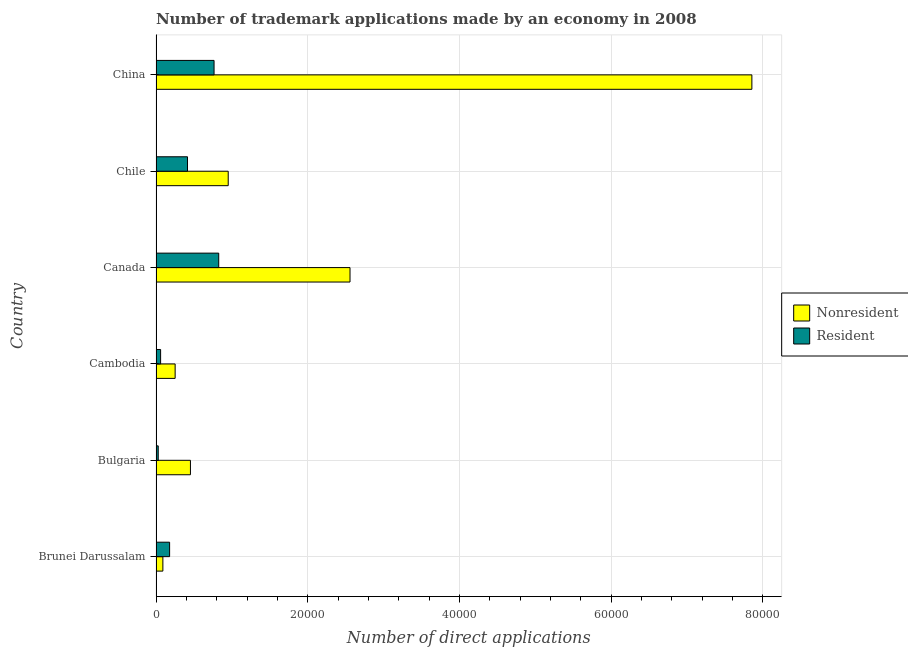Are the number of bars per tick equal to the number of legend labels?
Your response must be concise. Yes. How many bars are there on the 3rd tick from the top?
Make the answer very short. 2. What is the label of the 1st group of bars from the top?
Provide a short and direct response. China. In how many cases, is the number of bars for a given country not equal to the number of legend labels?
Your answer should be compact. 0. What is the number of trademark applications made by residents in Bulgaria?
Provide a short and direct response. 292. Across all countries, what is the maximum number of trademark applications made by non residents?
Ensure brevity in your answer.  7.86e+04. Across all countries, what is the minimum number of trademark applications made by non residents?
Keep it short and to the point. 904. In which country was the number of trademark applications made by residents maximum?
Offer a very short reply. Canada. In which country was the number of trademark applications made by residents minimum?
Make the answer very short. Bulgaria. What is the total number of trademark applications made by residents in the graph?
Give a very brief answer. 2.28e+04. What is the difference between the number of trademark applications made by non residents in Bulgaria and that in China?
Your answer should be compact. -7.40e+04. What is the difference between the number of trademark applications made by residents in Canada and the number of trademark applications made by non residents in Cambodia?
Your answer should be very brief. 5746. What is the average number of trademark applications made by residents per country?
Provide a succinct answer. 3793. What is the difference between the number of trademark applications made by residents and number of trademark applications made by non residents in China?
Your answer should be compact. -7.09e+04. What is the ratio of the number of trademark applications made by non residents in Canada to that in Chile?
Ensure brevity in your answer.  2.69. What is the difference between the highest and the second highest number of trademark applications made by residents?
Your response must be concise. 615. What is the difference between the highest and the lowest number of trademark applications made by non residents?
Give a very brief answer. 7.77e+04. In how many countries, is the number of trademark applications made by non residents greater than the average number of trademark applications made by non residents taken over all countries?
Keep it short and to the point. 2. What does the 2nd bar from the top in Cambodia represents?
Offer a terse response. Nonresident. What does the 1st bar from the bottom in Chile represents?
Make the answer very short. Nonresident. How many bars are there?
Your answer should be compact. 12. How many countries are there in the graph?
Your answer should be compact. 6. What is the difference between two consecutive major ticks on the X-axis?
Provide a short and direct response. 2.00e+04. Are the values on the major ticks of X-axis written in scientific E-notation?
Provide a short and direct response. No. Where does the legend appear in the graph?
Keep it short and to the point. Center right. How many legend labels are there?
Offer a very short reply. 2. How are the legend labels stacked?
Provide a succinct answer. Vertical. What is the title of the graph?
Ensure brevity in your answer.  Number of trademark applications made by an economy in 2008. What is the label or title of the X-axis?
Your response must be concise. Number of direct applications. What is the label or title of the Y-axis?
Offer a very short reply. Country. What is the Number of direct applications in Nonresident in Brunei Darussalam?
Keep it short and to the point. 904. What is the Number of direct applications of Resident in Brunei Darussalam?
Your answer should be compact. 1792. What is the Number of direct applications in Nonresident in Bulgaria?
Ensure brevity in your answer.  4538. What is the Number of direct applications in Resident in Bulgaria?
Keep it short and to the point. 292. What is the Number of direct applications of Nonresident in Cambodia?
Offer a terse response. 2521. What is the Number of direct applications in Resident in Cambodia?
Ensure brevity in your answer.  604. What is the Number of direct applications in Nonresident in Canada?
Offer a terse response. 2.56e+04. What is the Number of direct applications of Resident in Canada?
Offer a terse response. 8267. What is the Number of direct applications of Nonresident in Chile?
Offer a very short reply. 9519. What is the Number of direct applications in Resident in Chile?
Your answer should be compact. 4151. What is the Number of direct applications in Nonresident in China?
Offer a very short reply. 7.86e+04. What is the Number of direct applications of Resident in China?
Offer a terse response. 7652. Across all countries, what is the maximum Number of direct applications in Nonresident?
Give a very brief answer. 7.86e+04. Across all countries, what is the maximum Number of direct applications of Resident?
Make the answer very short. 8267. Across all countries, what is the minimum Number of direct applications of Nonresident?
Provide a succinct answer. 904. Across all countries, what is the minimum Number of direct applications in Resident?
Make the answer very short. 292. What is the total Number of direct applications in Nonresident in the graph?
Give a very brief answer. 1.22e+05. What is the total Number of direct applications in Resident in the graph?
Your answer should be compact. 2.28e+04. What is the difference between the Number of direct applications in Nonresident in Brunei Darussalam and that in Bulgaria?
Provide a succinct answer. -3634. What is the difference between the Number of direct applications of Resident in Brunei Darussalam and that in Bulgaria?
Ensure brevity in your answer.  1500. What is the difference between the Number of direct applications in Nonresident in Brunei Darussalam and that in Cambodia?
Ensure brevity in your answer.  -1617. What is the difference between the Number of direct applications in Resident in Brunei Darussalam and that in Cambodia?
Offer a very short reply. 1188. What is the difference between the Number of direct applications of Nonresident in Brunei Darussalam and that in Canada?
Your answer should be compact. -2.47e+04. What is the difference between the Number of direct applications in Resident in Brunei Darussalam and that in Canada?
Your answer should be very brief. -6475. What is the difference between the Number of direct applications in Nonresident in Brunei Darussalam and that in Chile?
Provide a succinct answer. -8615. What is the difference between the Number of direct applications in Resident in Brunei Darussalam and that in Chile?
Provide a succinct answer. -2359. What is the difference between the Number of direct applications in Nonresident in Brunei Darussalam and that in China?
Provide a succinct answer. -7.77e+04. What is the difference between the Number of direct applications of Resident in Brunei Darussalam and that in China?
Provide a succinct answer. -5860. What is the difference between the Number of direct applications in Nonresident in Bulgaria and that in Cambodia?
Provide a short and direct response. 2017. What is the difference between the Number of direct applications of Resident in Bulgaria and that in Cambodia?
Keep it short and to the point. -312. What is the difference between the Number of direct applications of Nonresident in Bulgaria and that in Canada?
Your answer should be very brief. -2.10e+04. What is the difference between the Number of direct applications in Resident in Bulgaria and that in Canada?
Offer a terse response. -7975. What is the difference between the Number of direct applications in Nonresident in Bulgaria and that in Chile?
Your response must be concise. -4981. What is the difference between the Number of direct applications in Resident in Bulgaria and that in Chile?
Give a very brief answer. -3859. What is the difference between the Number of direct applications of Nonresident in Bulgaria and that in China?
Make the answer very short. -7.40e+04. What is the difference between the Number of direct applications of Resident in Bulgaria and that in China?
Ensure brevity in your answer.  -7360. What is the difference between the Number of direct applications in Nonresident in Cambodia and that in Canada?
Your response must be concise. -2.31e+04. What is the difference between the Number of direct applications in Resident in Cambodia and that in Canada?
Provide a short and direct response. -7663. What is the difference between the Number of direct applications in Nonresident in Cambodia and that in Chile?
Provide a short and direct response. -6998. What is the difference between the Number of direct applications in Resident in Cambodia and that in Chile?
Ensure brevity in your answer.  -3547. What is the difference between the Number of direct applications of Nonresident in Cambodia and that in China?
Make the answer very short. -7.60e+04. What is the difference between the Number of direct applications in Resident in Cambodia and that in China?
Provide a short and direct response. -7048. What is the difference between the Number of direct applications of Nonresident in Canada and that in Chile?
Offer a terse response. 1.61e+04. What is the difference between the Number of direct applications in Resident in Canada and that in Chile?
Offer a very short reply. 4116. What is the difference between the Number of direct applications of Nonresident in Canada and that in China?
Ensure brevity in your answer.  -5.30e+04. What is the difference between the Number of direct applications in Resident in Canada and that in China?
Your response must be concise. 615. What is the difference between the Number of direct applications of Nonresident in Chile and that in China?
Your response must be concise. -6.90e+04. What is the difference between the Number of direct applications of Resident in Chile and that in China?
Provide a short and direct response. -3501. What is the difference between the Number of direct applications in Nonresident in Brunei Darussalam and the Number of direct applications in Resident in Bulgaria?
Give a very brief answer. 612. What is the difference between the Number of direct applications of Nonresident in Brunei Darussalam and the Number of direct applications of Resident in Cambodia?
Your answer should be very brief. 300. What is the difference between the Number of direct applications in Nonresident in Brunei Darussalam and the Number of direct applications in Resident in Canada?
Provide a short and direct response. -7363. What is the difference between the Number of direct applications of Nonresident in Brunei Darussalam and the Number of direct applications of Resident in Chile?
Provide a succinct answer. -3247. What is the difference between the Number of direct applications in Nonresident in Brunei Darussalam and the Number of direct applications in Resident in China?
Provide a succinct answer. -6748. What is the difference between the Number of direct applications of Nonresident in Bulgaria and the Number of direct applications of Resident in Cambodia?
Your answer should be very brief. 3934. What is the difference between the Number of direct applications in Nonresident in Bulgaria and the Number of direct applications in Resident in Canada?
Offer a very short reply. -3729. What is the difference between the Number of direct applications in Nonresident in Bulgaria and the Number of direct applications in Resident in Chile?
Keep it short and to the point. 387. What is the difference between the Number of direct applications in Nonresident in Bulgaria and the Number of direct applications in Resident in China?
Ensure brevity in your answer.  -3114. What is the difference between the Number of direct applications in Nonresident in Cambodia and the Number of direct applications in Resident in Canada?
Offer a very short reply. -5746. What is the difference between the Number of direct applications in Nonresident in Cambodia and the Number of direct applications in Resident in Chile?
Your answer should be compact. -1630. What is the difference between the Number of direct applications in Nonresident in Cambodia and the Number of direct applications in Resident in China?
Your response must be concise. -5131. What is the difference between the Number of direct applications in Nonresident in Canada and the Number of direct applications in Resident in Chile?
Your answer should be compact. 2.14e+04. What is the difference between the Number of direct applications of Nonresident in Canada and the Number of direct applications of Resident in China?
Your answer should be very brief. 1.79e+04. What is the difference between the Number of direct applications in Nonresident in Chile and the Number of direct applications in Resident in China?
Provide a short and direct response. 1867. What is the average Number of direct applications in Nonresident per country?
Keep it short and to the point. 2.03e+04. What is the average Number of direct applications in Resident per country?
Give a very brief answer. 3793. What is the difference between the Number of direct applications in Nonresident and Number of direct applications in Resident in Brunei Darussalam?
Provide a short and direct response. -888. What is the difference between the Number of direct applications of Nonresident and Number of direct applications of Resident in Bulgaria?
Your response must be concise. 4246. What is the difference between the Number of direct applications of Nonresident and Number of direct applications of Resident in Cambodia?
Provide a short and direct response. 1917. What is the difference between the Number of direct applications in Nonresident and Number of direct applications in Resident in Canada?
Offer a very short reply. 1.73e+04. What is the difference between the Number of direct applications of Nonresident and Number of direct applications of Resident in Chile?
Your answer should be compact. 5368. What is the difference between the Number of direct applications in Nonresident and Number of direct applications in Resident in China?
Provide a short and direct response. 7.09e+04. What is the ratio of the Number of direct applications of Nonresident in Brunei Darussalam to that in Bulgaria?
Keep it short and to the point. 0.2. What is the ratio of the Number of direct applications of Resident in Brunei Darussalam to that in Bulgaria?
Give a very brief answer. 6.14. What is the ratio of the Number of direct applications in Nonresident in Brunei Darussalam to that in Cambodia?
Your answer should be very brief. 0.36. What is the ratio of the Number of direct applications in Resident in Brunei Darussalam to that in Cambodia?
Offer a terse response. 2.97. What is the ratio of the Number of direct applications of Nonresident in Brunei Darussalam to that in Canada?
Offer a very short reply. 0.04. What is the ratio of the Number of direct applications of Resident in Brunei Darussalam to that in Canada?
Your response must be concise. 0.22. What is the ratio of the Number of direct applications in Nonresident in Brunei Darussalam to that in Chile?
Provide a short and direct response. 0.1. What is the ratio of the Number of direct applications in Resident in Brunei Darussalam to that in Chile?
Provide a succinct answer. 0.43. What is the ratio of the Number of direct applications of Nonresident in Brunei Darussalam to that in China?
Provide a succinct answer. 0.01. What is the ratio of the Number of direct applications of Resident in Brunei Darussalam to that in China?
Your answer should be very brief. 0.23. What is the ratio of the Number of direct applications of Nonresident in Bulgaria to that in Cambodia?
Your response must be concise. 1.8. What is the ratio of the Number of direct applications in Resident in Bulgaria to that in Cambodia?
Your response must be concise. 0.48. What is the ratio of the Number of direct applications in Nonresident in Bulgaria to that in Canada?
Your answer should be very brief. 0.18. What is the ratio of the Number of direct applications of Resident in Bulgaria to that in Canada?
Make the answer very short. 0.04. What is the ratio of the Number of direct applications of Nonresident in Bulgaria to that in Chile?
Provide a succinct answer. 0.48. What is the ratio of the Number of direct applications in Resident in Bulgaria to that in Chile?
Your response must be concise. 0.07. What is the ratio of the Number of direct applications of Nonresident in Bulgaria to that in China?
Offer a terse response. 0.06. What is the ratio of the Number of direct applications in Resident in Bulgaria to that in China?
Your response must be concise. 0.04. What is the ratio of the Number of direct applications in Nonresident in Cambodia to that in Canada?
Keep it short and to the point. 0.1. What is the ratio of the Number of direct applications of Resident in Cambodia to that in Canada?
Make the answer very short. 0.07. What is the ratio of the Number of direct applications of Nonresident in Cambodia to that in Chile?
Your answer should be compact. 0.26. What is the ratio of the Number of direct applications in Resident in Cambodia to that in Chile?
Ensure brevity in your answer.  0.15. What is the ratio of the Number of direct applications of Nonresident in Cambodia to that in China?
Keep it short and to the point. 0.03. What is the ratio of the Number of direct applications of Resident in Cambodia to that in China?
Your answer should be very brief. 0.08. What is the ratio of the Number of direct applications of Nonresident in Canada to that in Chile?
Your answer should be very brief. 2.69. What is the ratio of the Number of direct applications in Resident in Canada to that in Chile?
Ensure brevity in your answer.  1.99. What is the ratio of the Number of direct applications of Nonresident in Canada to that in China?
Make the answer very short. 0.33. What is the ratio of the Number of direct applications in Resident in Canada to that in China?
Your response must be concise. 1.08. What is the ratio of the Number of direct applications of Nonresident in Chile to that in China?
Your answer should be very brief. 0.12. What is the ratio of the Number of direct applications of Resident in Chile to that in China?
Give a very brief answer. 0.54. What is the difference between the highest and the second highest Number of direct applications of Nonresident?
Give a very brief answer. 5.30e+04. What is the difference between the highest and the second highest Number of direct applications of Resident?
Make the answer very short. 615. What is the difference between the highest and the lowest Number of direct applications of Nonresident?
Your answer should be very brief. 7.77e+04. What is the difference between the highest and the lowest Number of direct applications in Resident?
Provide a succinct answer. 7975. 